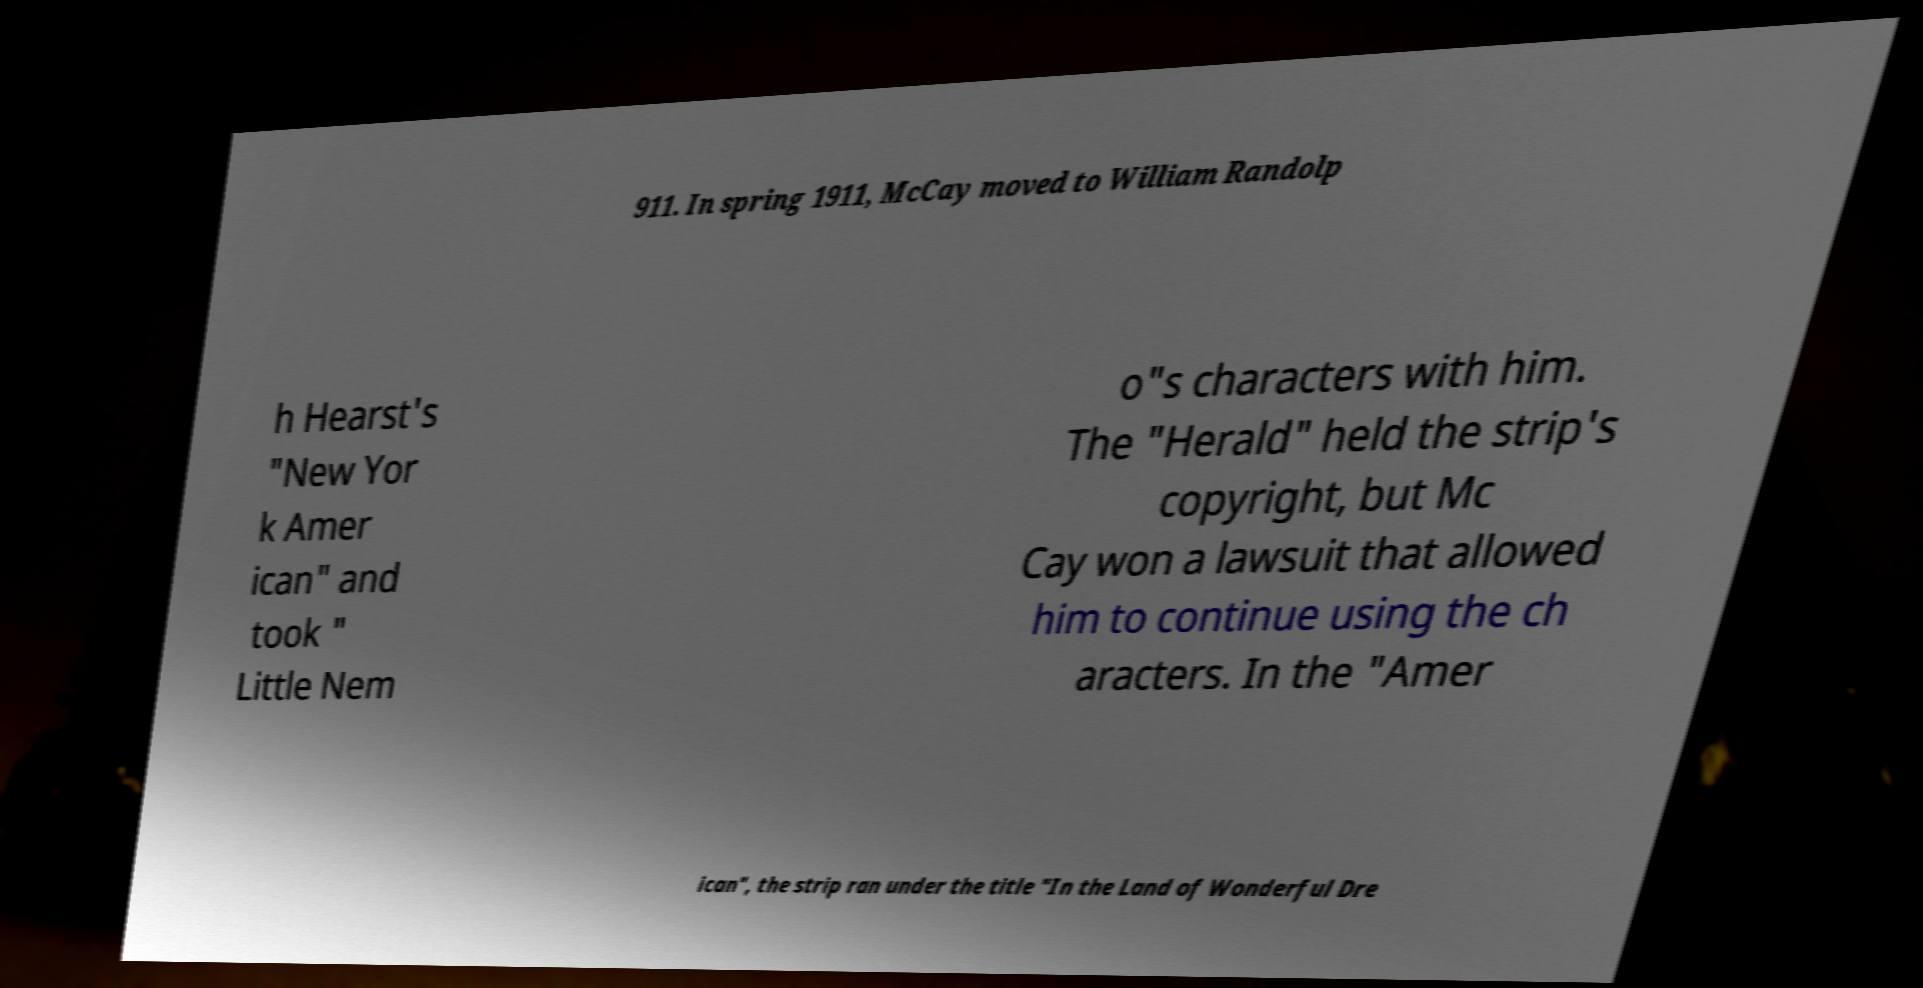For documentation purposes, I need the text within this image transcribed. Could you provide that? 911. In spring 1911, McCay moved to William Randolp h Hearst's "New Yor k Amer ican" and took " Little Nem o"s characters with him. The "Herald" held the strip's copyright, but Mc Cay won a lawsuit that allowed him to continue using the ch aracters. In the "Amer ican", the strip ran under the title "In the Land of Wonderful Dre 